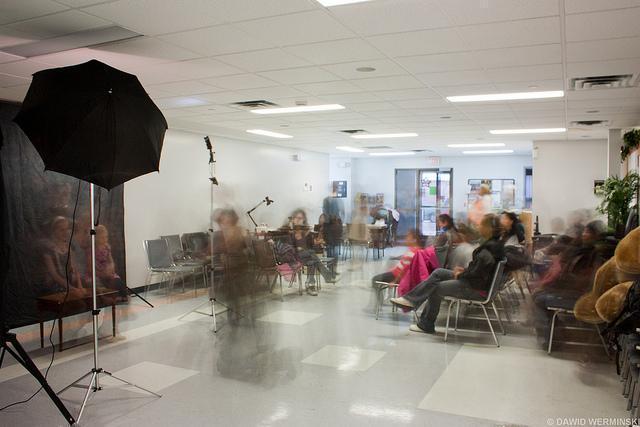What is the umbrella being used for?
Make your selection and explain in format: 'Answer: answer
Rationale: rationale.'
Options: Keeping dry, decoration, lighting, to dance. Answer: lighting.
Rationale: The umbrella is used for lighting a photo shoot. 